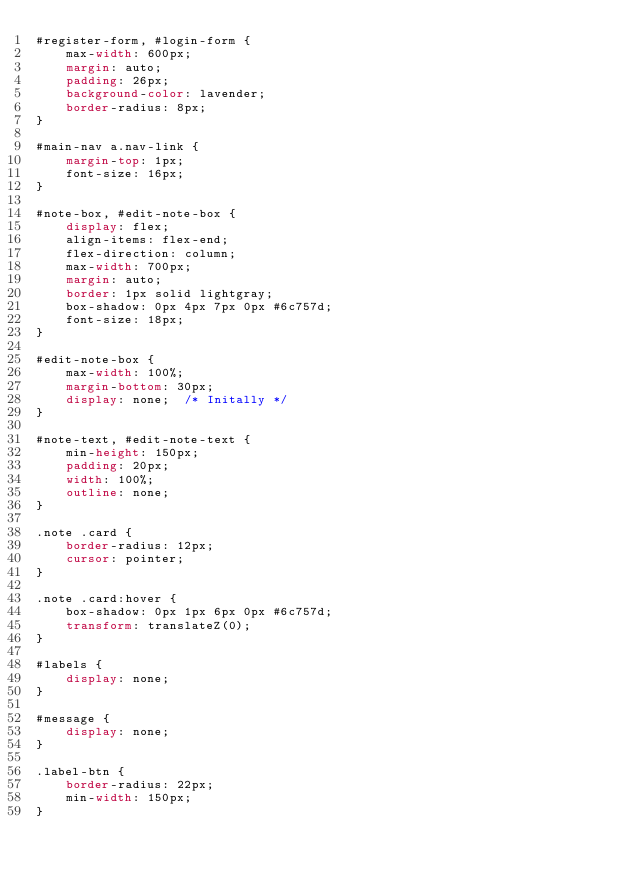<code> <loc_0><loc_0><loc_500><loc_500><_CSS_>#register-form, #login-form {
    max-width: 600px;
    margin: auto;
    padding: 26px;
    background-color: lavender;
    border-radius: 8px;
}

#main-nav a.nav-link {
    margin-top: 1px;
    font-size: 16px;
}

#note-box, #edit-note-box {
    display: flex;
    align-items: flex-end;
    flex-direction: column;
    max-width: 700px;
    margin: auto;
    border: 1px solid lightgray;
    box-shadow: 0px 4px 7px 0px #6c757d;
    font-size: 18px;
}

#edit-note-box {
    max-width: 100%;
    margin-bottom: 30px;
    display: none;  /* Initally */
}

#note-text, #edit-note-text {
    min-height: 150px;
    padding: 20px;
    width: 100%;
    outline: none;
}

.note .card {
    border-radius: 12px;
    cursor: pointer;
}

.note .card:hover {
    box-shadow: 0px 1px 6px 0px #6c757d;
    transform: translateZ(0);
}

#labels {
    display: none;
}

#message {
    display: none;
}

.label-btn {
    border-radius: 22px;
    min-width: 150px;
}
</code> 